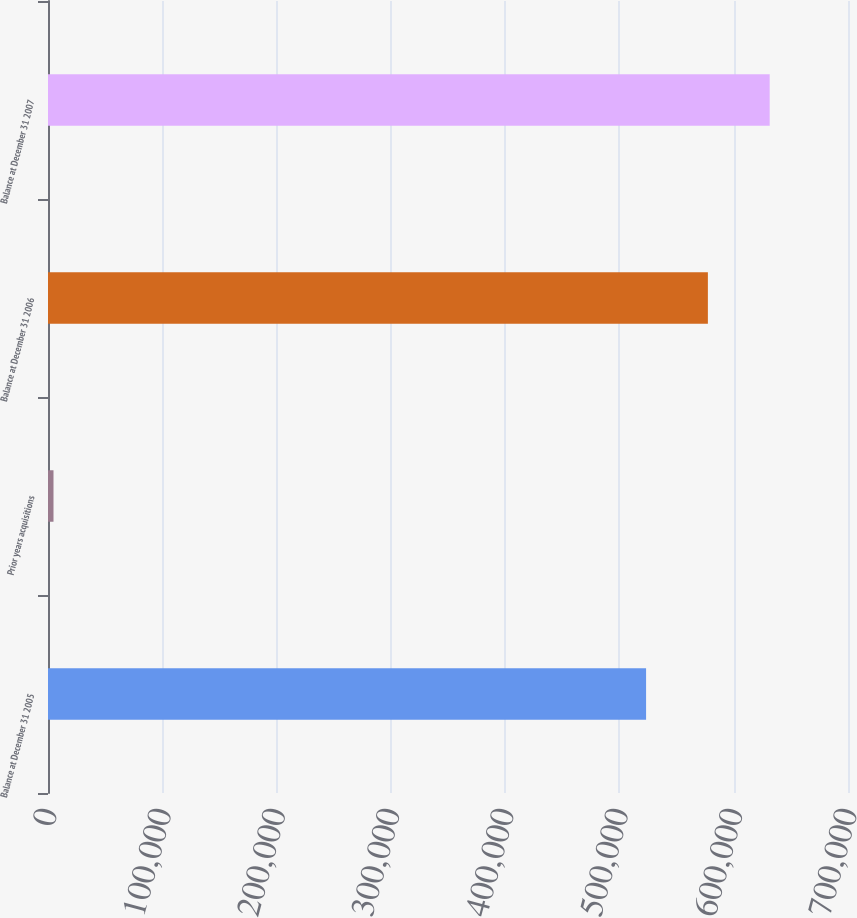<chart> <loc_0><loc_0><loc_500><loc_500><bar_chart><fcel>Balance at December 31 2005<fcel>Prior years acquisitions<fcel>Balance at December 31 2006<fcel>Balance at December 31 2007<nl><fcel>523315<fcel>4815<fcel>577395<fcel>631475<nl></chart> 